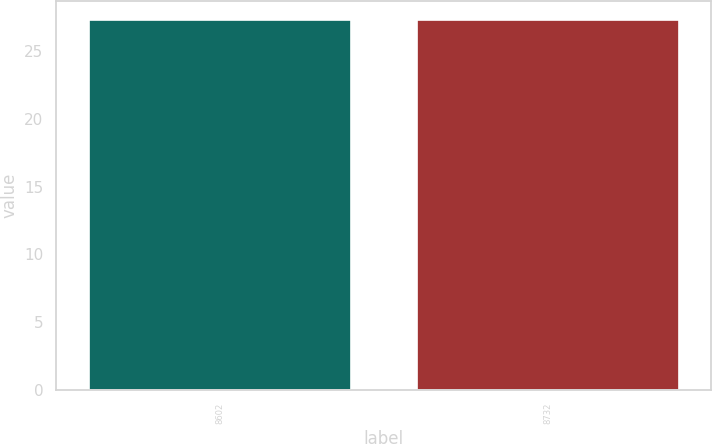<chart> <loc_0><loc_0><loc_500><loc_500><bar_chart><fcel>8602<fcel>8732<nl><fcel>27.33<fcel>27.34<nl></chart> 